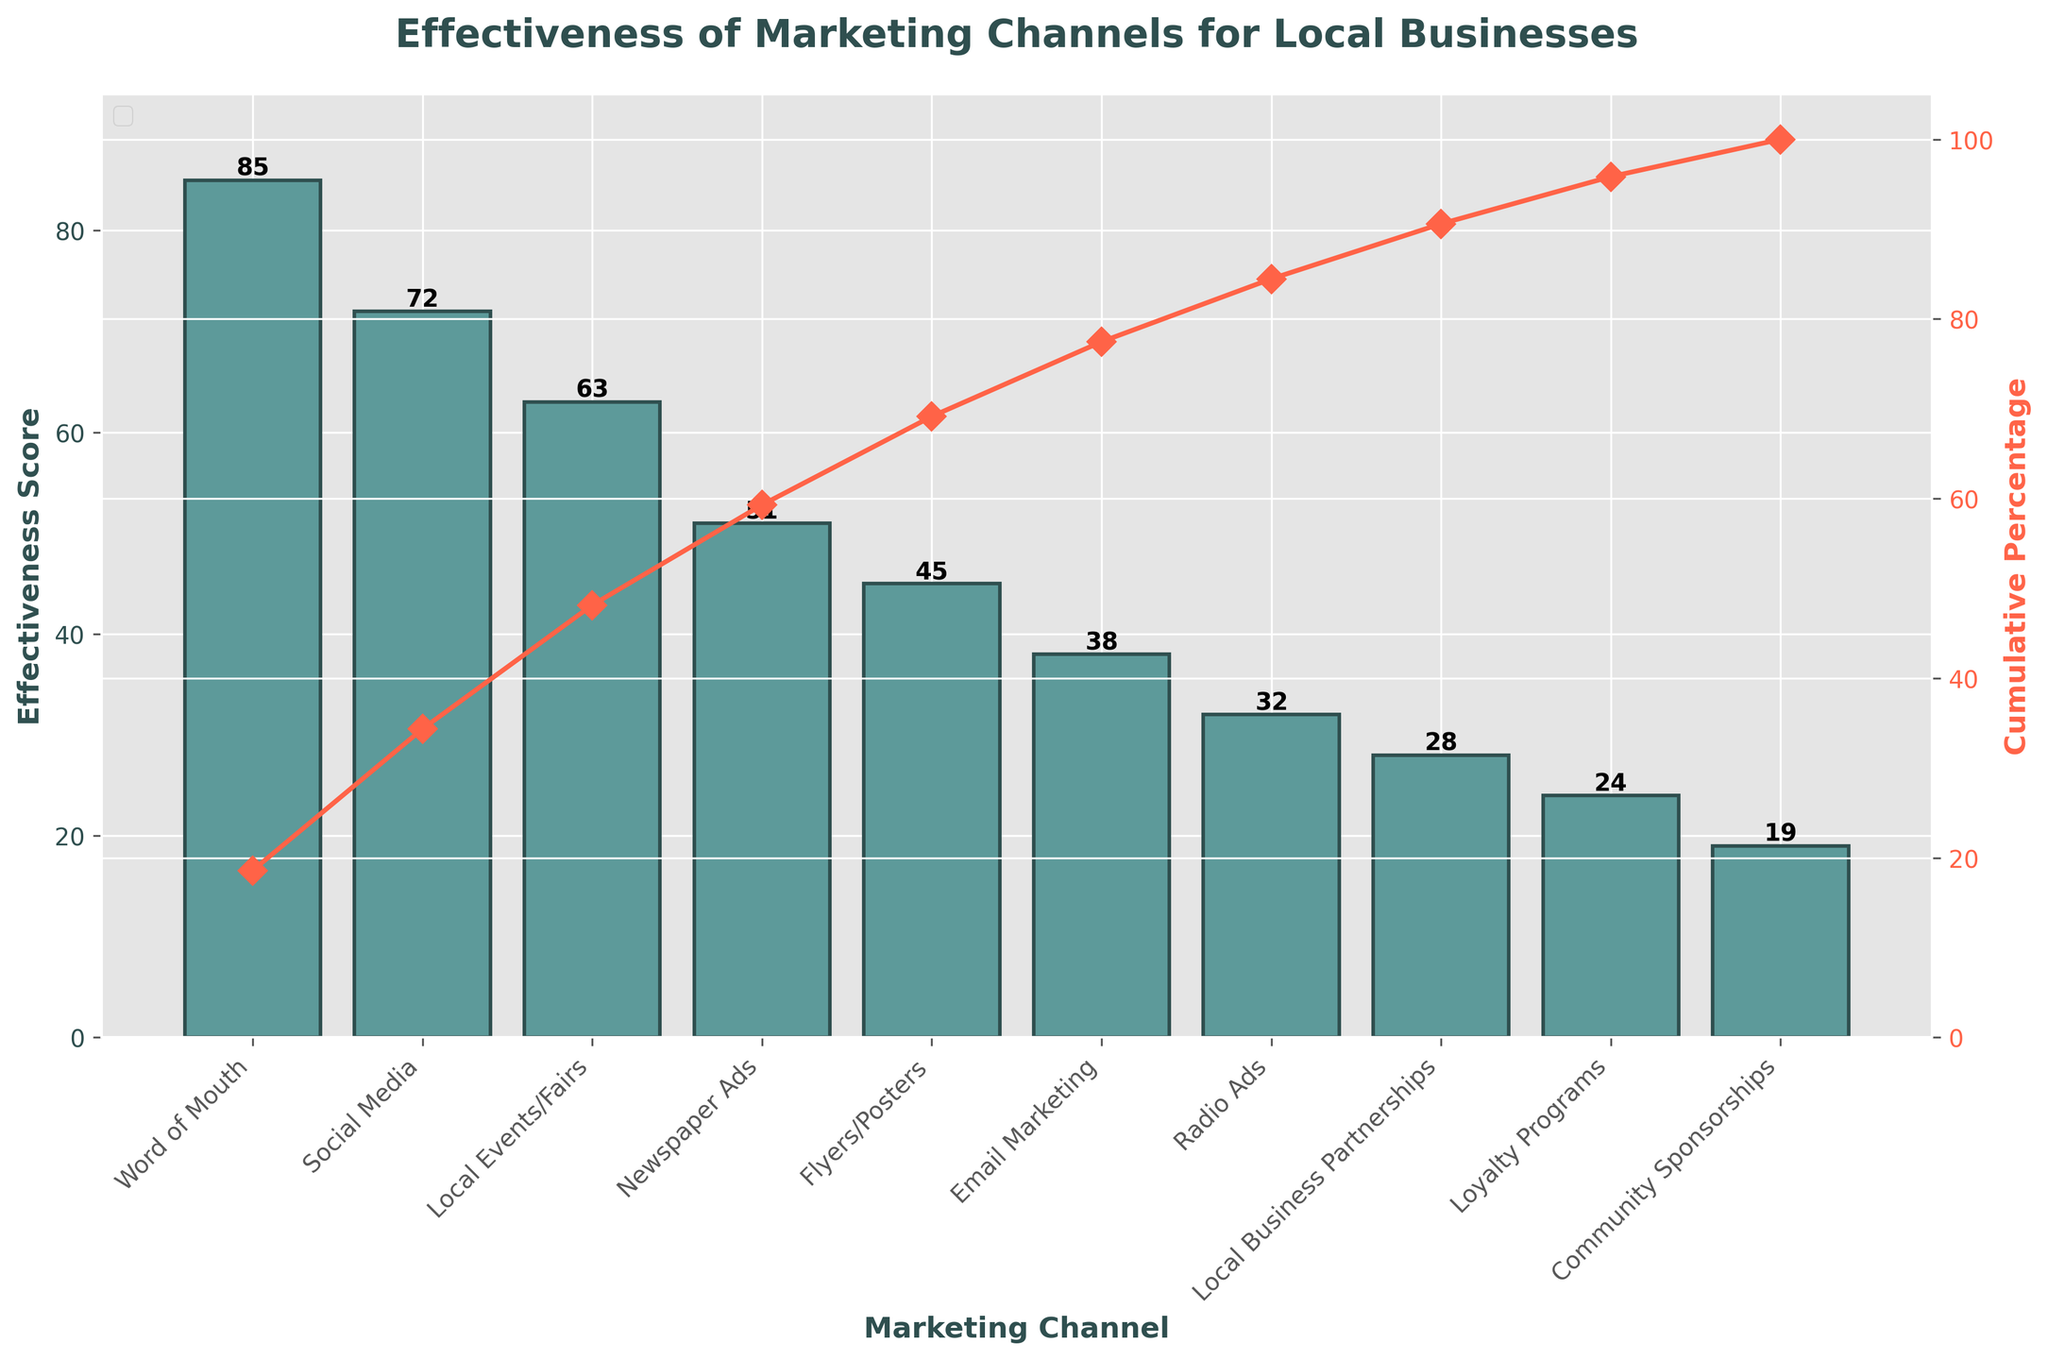What's the title of the figure? The title of the figure is displayed at the top, and it is a direct way to understand the overall topic of the chart. The title reads "Effectiveness of Marketing Channels for Local Businesses".
Answer: Effectiveness of Marketing Channels for Local Businesses What color are the bars representing the Effectiveness Score? The bars in the chart are visually distinct, colored in blue-green shades. The color used for the bars is #5D9A9A, as observed from the figure.
Answer: Blue-green How many marketing channels are represented in the chart? Count the number of bars in the bar chart. Each bar represents one marketing channel. There are ten bars present in the chart.
Answer: 10 Which marketing channel has the highest Effectiveness Score? Look at the bar with the greatest height. The tallest bar represents Word of Mouth, which has the highest Effectiveness Score of 85.
Answer: Word of Mouth What is the cumulative percentage corresponding to Social Media? Identify the point on the cumulative percentage line that corresponds to Social Media. The cumulative percentage for Social Media is 40% when adding its Effectiveness Score (72) to the previous score (Word of Mouth, 85) and dividing by the total. ( (85+72)/457*100 ≈ 40%)
Answer: 40% How much more effective is Word of Mouth compared to Community Sponsorships? Subtract the Effectiveness Score of Community Sponsorships from that of Word of Mouth. The score for Word of Mouth is 85, and for Community Sponsorships, it is 19. Therefore, the difference is 85 - 19 = 66.
Answer: 66 Which is more effective: Local Events/Fairs or Email Marketing? Compare the height of the bars representing Local Events/Fairs and Email Marketing. The Effectiveness Score for Local Events/Fairs is 63, and for Email Marketing, it is 38. Thus, Local Events/Fairs is more effective.
Answer: Local Events/Fairs What is the combined Effectiveness Score for Newspaper Ads, Flyers/Posters, and Local Business Partnerships? Sum the Effectiveness Scores of Newspaper Ads (51), Flyers/Posters (45), and Local Business Partnerships (28). The combined score is 51 + 45 + 28 = 124.
Answer: 124 At what cumulative percentage do Loyalty Programs contribute? Identify the cumulative percentage associated with Loyalty Programs on the line plot. Adding the Effectiveness Scores up to and including Loyalty Programs (85+72+63+51+45+38+32+28+24)/457*100 ≈ 92%).
Answer: 92% Which marketing channels together make up over half of the total Effectiveness Score? Determine the channels that, when summed, make up more than 50% cumulative percentage. Adding the Effectiveness Scores from highest (Word of Mouth) to lower, (85+72+63+51+45)/457*100 ≈ 69%, so Word of Mouth, Social Media, Local Events/Fairs, Newspaper Ads, and Flyers/Posters together exceed half of the total.
Answer: Word of Mouth, Social Media, Local Events/Fairs, Newspaper Ads, Flyers/Posters 